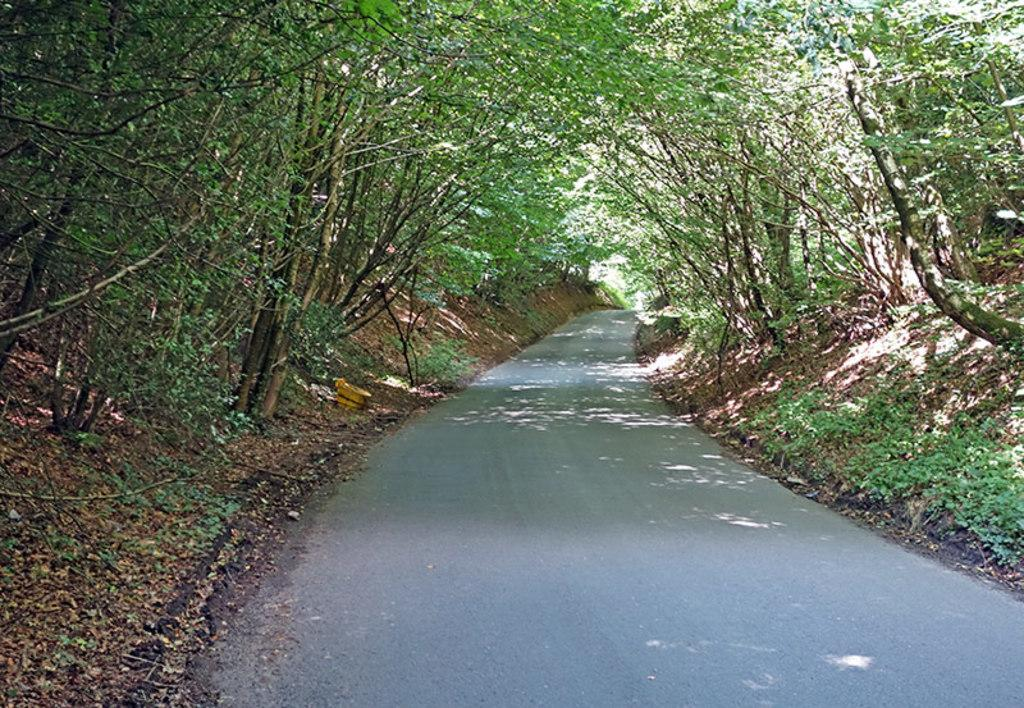What is the main feature of the image? There is a road in the image. What can be seen around the road? There is a lot of grass and trees around the road. Are there any dinosaurs visible in the image? No, there are no dinosaurs present in the image. 